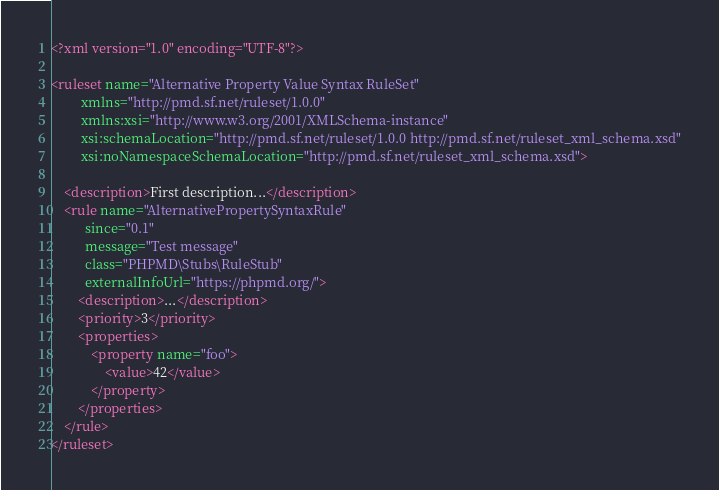Convert code to text. <code><loc_0><loc_0><loc_500><loc_500><_XML_><?xml version="1.0" encoding="UTF-8"?>

<ruleset name="Alternative Property Value Syntax RuleSet"
         xmlns="http://pmd.sf.net/ruleset/1.0.0"
         xmlns:xsi="http://www.w3.org/2001/XMLSchema-instance"
         xsi:schemaLocation="http://pmd.sf.net/ruleset/1.0.0 http://pmd.sf.net/ruleset_xml_schema.xsd"
         xsi:noNamespaceSchemaLocation="http://pmd.sf.net/ruleset_xml_schema.xsd">

    <description>First description...</description>
    <rule name="AlternativePropertySyntaxRule"
          since="0.1"
          message="Test message"
          class="PHPMD\Stubs\RuleStub"
          externalInfoUrl="https://phpmd.org/">
        <description>...</description>
        <priority>3</priority>
        <properties>
            <property name="foo">
                <value>42</value>
            </property>
        </properties>
    </rule>
</ruleset>
</code> 